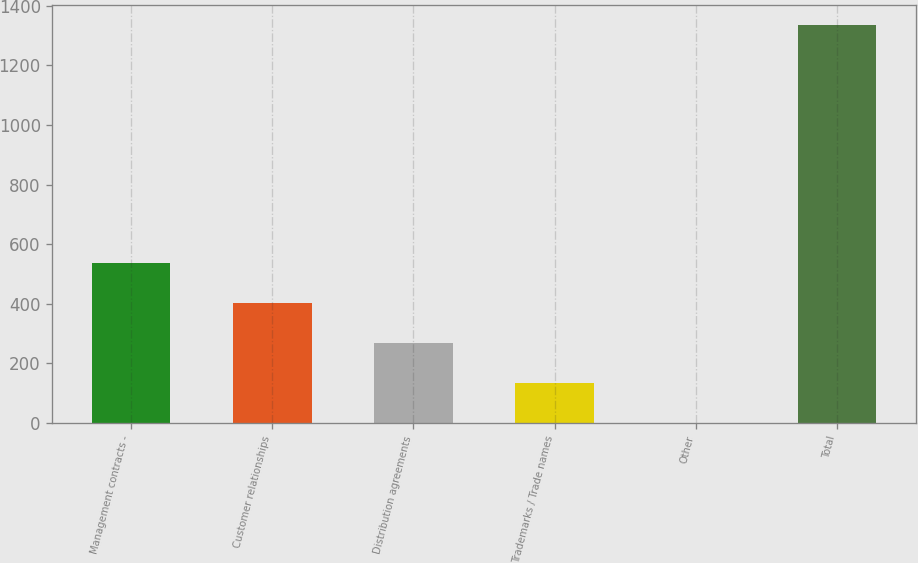<chart> <loc_0><loc_0><loc_500><loc_500><bar_chart><fcel>Management contracts -<fcel>Customer relationships<fcel>Distribution agreements<fcel>Trademarks / Trade names<fcel>Other<fcel>Total<nl><fcel>535.48<fcel>401.86<fcel>268.24<fcel>134.62<fcel>1<fcel>1337.2<nl></chart> 